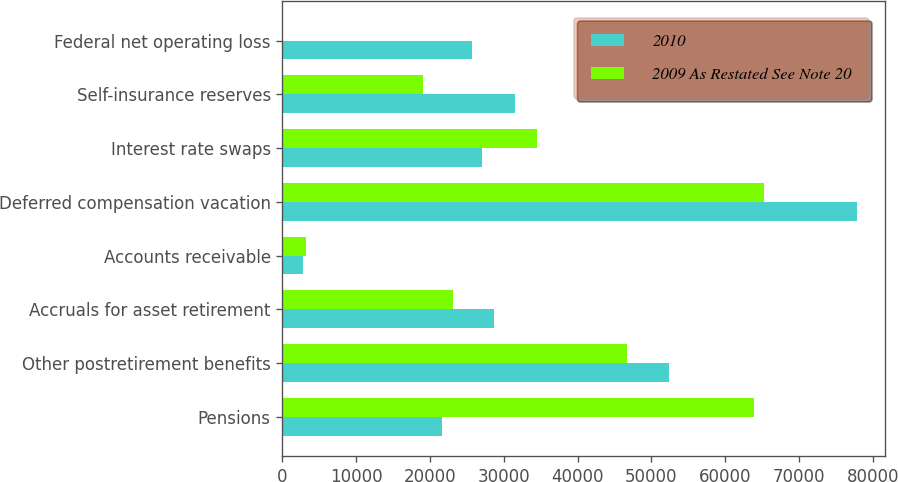Convert chart to OTSL. <chart><loc_0><loc_0><loc_500><loc_500><stacked_bar_chart><ecel><fcel>Pensions<fcel>Other postretirement benefits<fcel>Accruals for asset retirement<fcel>Accounts receivable<fcel>Deferred compensation vacation<fcel>Interest rate swaps<fcel>Self-insurance reserves<fcel>Federal net operating loss<nl><fcel>2010<fcel>21630<fcel>52366<fcel>28605<fcel>2770<fcel>77793<fcel>27022<fcel>31445<fcel>25629<nl><fcel>2009 As Restated See Note 20<fcel>63881<fcel>46718<fcel>23128<fcel>3165<fcel>65308<fcel>34468<fcel>19022<fcel>0<nl></chart> 